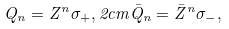Convert formula to latex. <formula><loc_0><loc_0><loc_500><loc_500>Q _ { n } = Z ^ { n } \sigma _ { + } , 2 c m \bar { Q } _ { n } = \bar { Z } ^ { n } \sigma _ { - } ,</formula> 